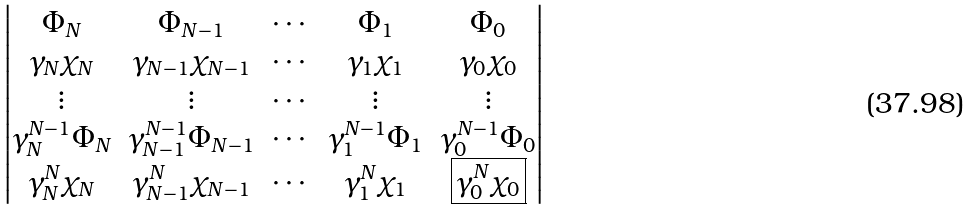Convert formula to latex. <formula><loc_0><loc_0><loc_500><loc_500>\begin{vmatrix} \Phi _ { N } & \Phi _ { N - 1 } & \cdots & \Phi _ { 1 } & \Phi _ { 0 } \\ \gamma _ { N } \chi _ { N } & \gamma _ { N - 1 } \chi _ { N - 1 } & \cdots & \gamma _ { 1 } \chi _ { 1 } & \gamma _ { 0 } \chi _ { 0 } \\ \vdots & \vdots & \cdots & \vdots & \vdots \\ \gamma ^ { N - 1 } _ { N } \Phi _ { N } & \gamma ^ { N - 1 } _ { N - 1 } \Phi _ { N - 1 } & \cdots & \gamma ^ { N - 1 } _ { 1 } \Phi _ { 1 } & \gamma ^ { N - 1 } _ { 0 } \Phi _ { 0 } \\ \gamma ^ { N } _ { N } \chi _ { N } & \gamma ^ { N } _ { N - 1 } \chi _ { N - 1 } & \cdots & \gamma ^ { N } _ { 1 } \chi _ { 1 } & { \boxed { \gamma ^ { N } _ { 0 } \chi _ { 0 } } } \end{vmatrix}</formula> 